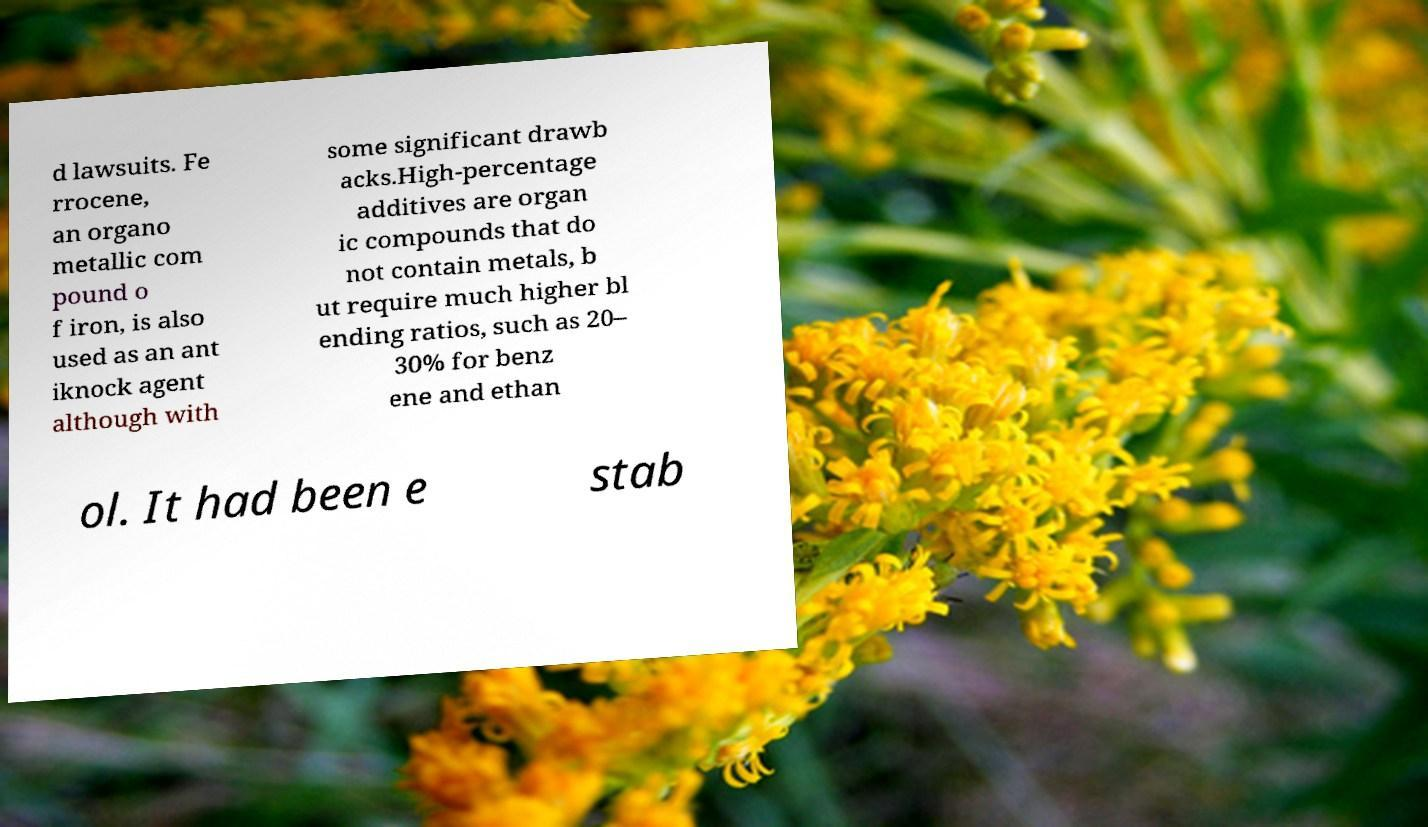Can you read and provide the text displayed in the image?This photo seems to have some interesting text. Can you extract and type it out for me? d lawsuits. Fe rrocene, an organo metallic com pound o f iron, is also used as an ant iknock agent although with some significant drawb acks.High-percentage additives are organ ic compounds that do not contain metals, b ut require much higher bl ending ratios, such as 20– 30% for benz ene and ethan ol. It had been e stab 